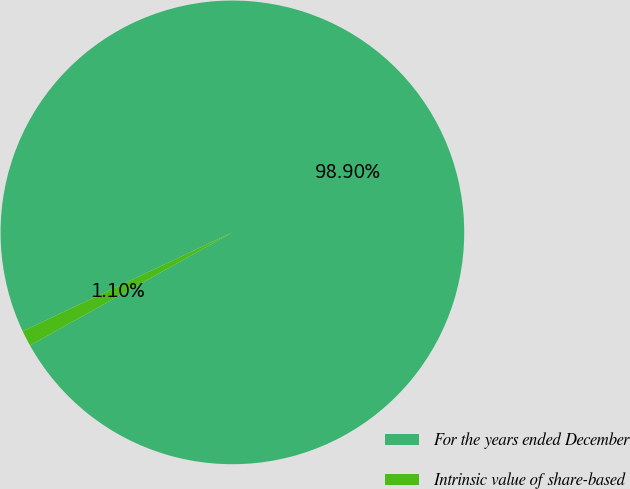<chart> <loc_0><loc_0><loc_500><loc_500><pie_chart><fcel>For the years ended December<fcel>Intrinsic value of share-based<nl><fcel>98.9%<fcel>1.1%<nl></chart> 